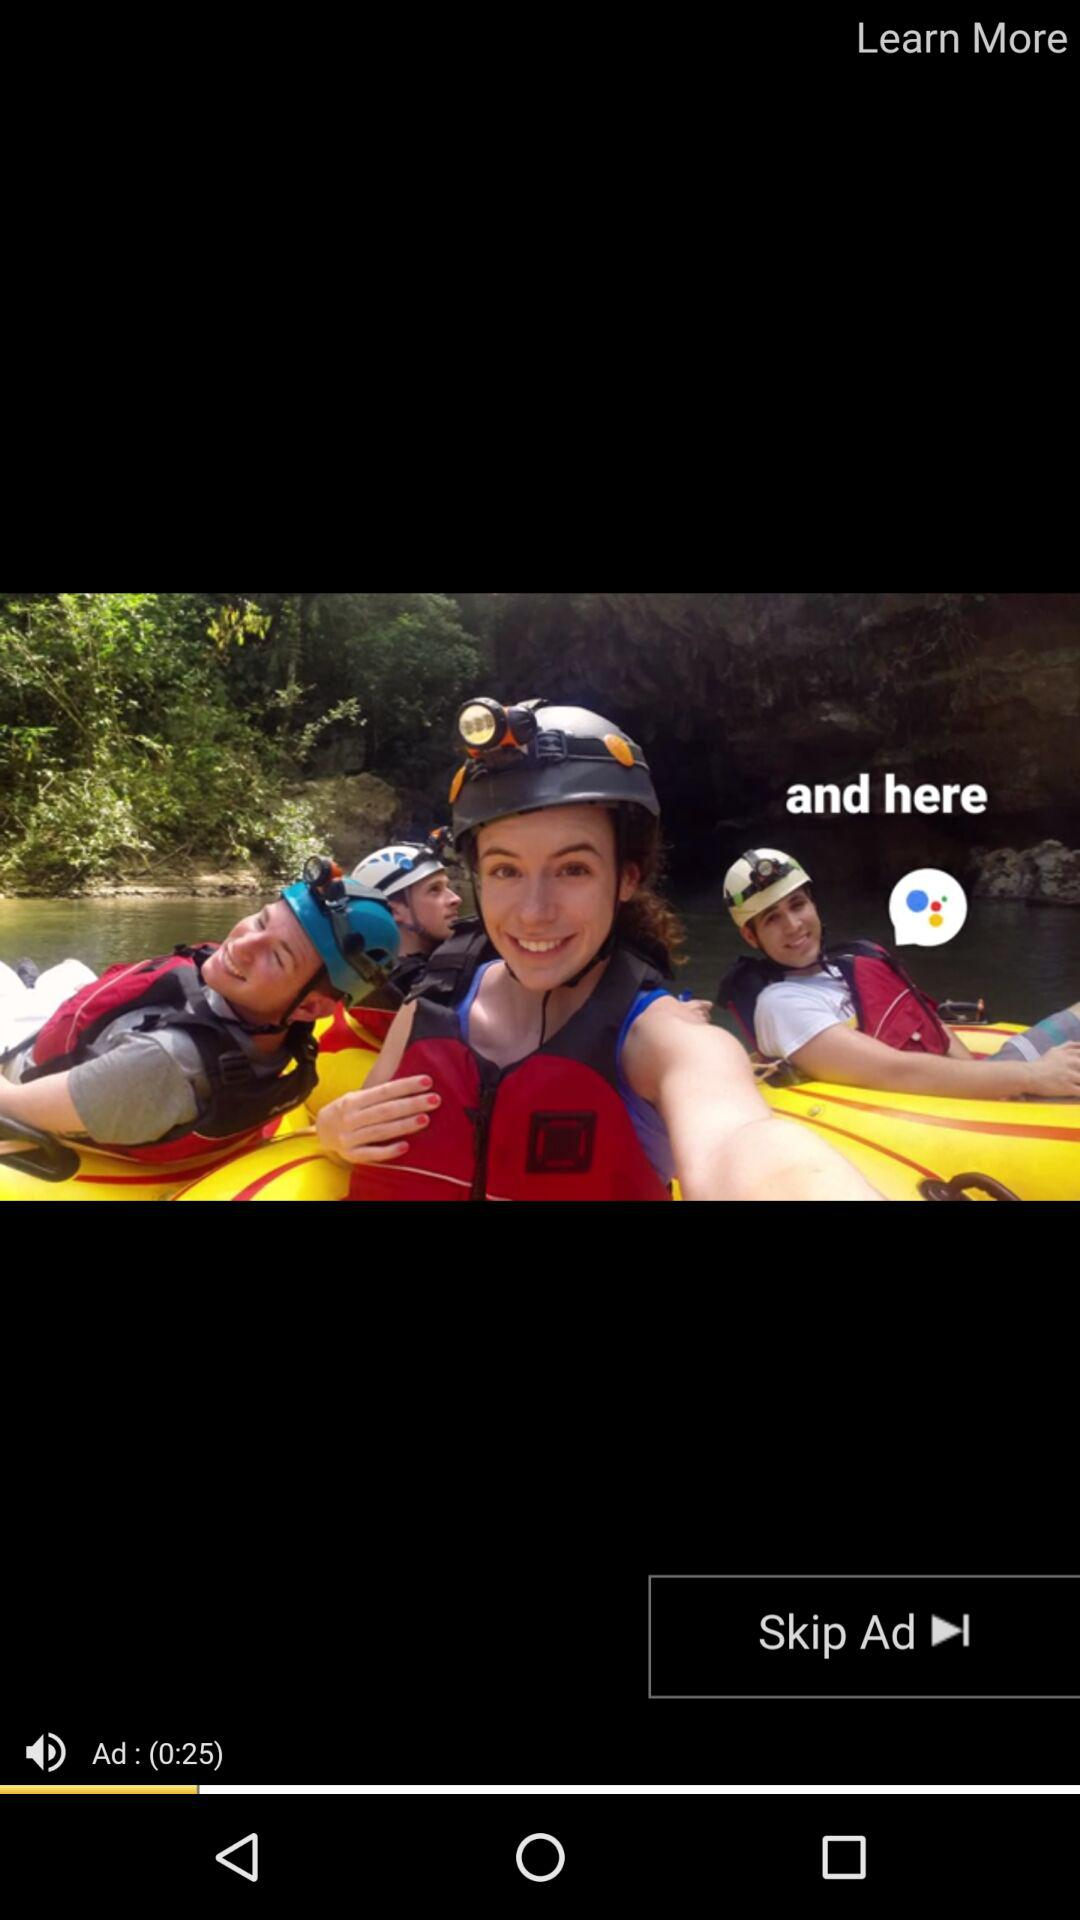How many seconds long is the ad?
Answer the question using a single word or phrase. 25 